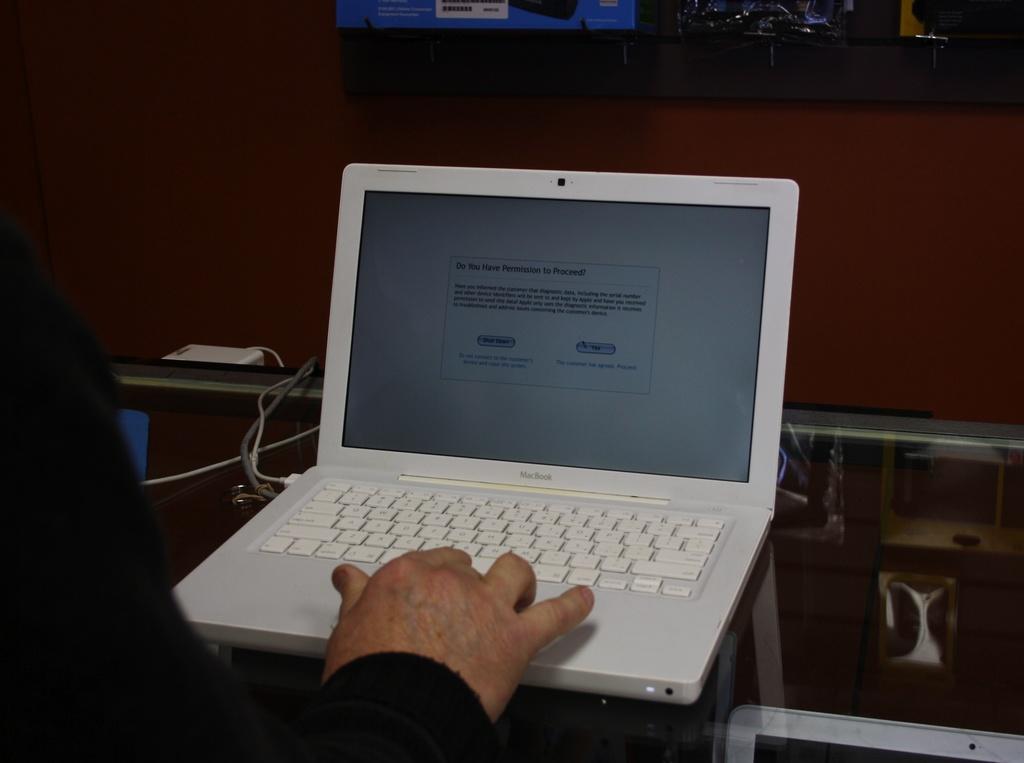What does the banner say?
Your response must be concise. Do you have permission to proceed. What type of laptop is this?
Offer a very short reply. Macbook. 